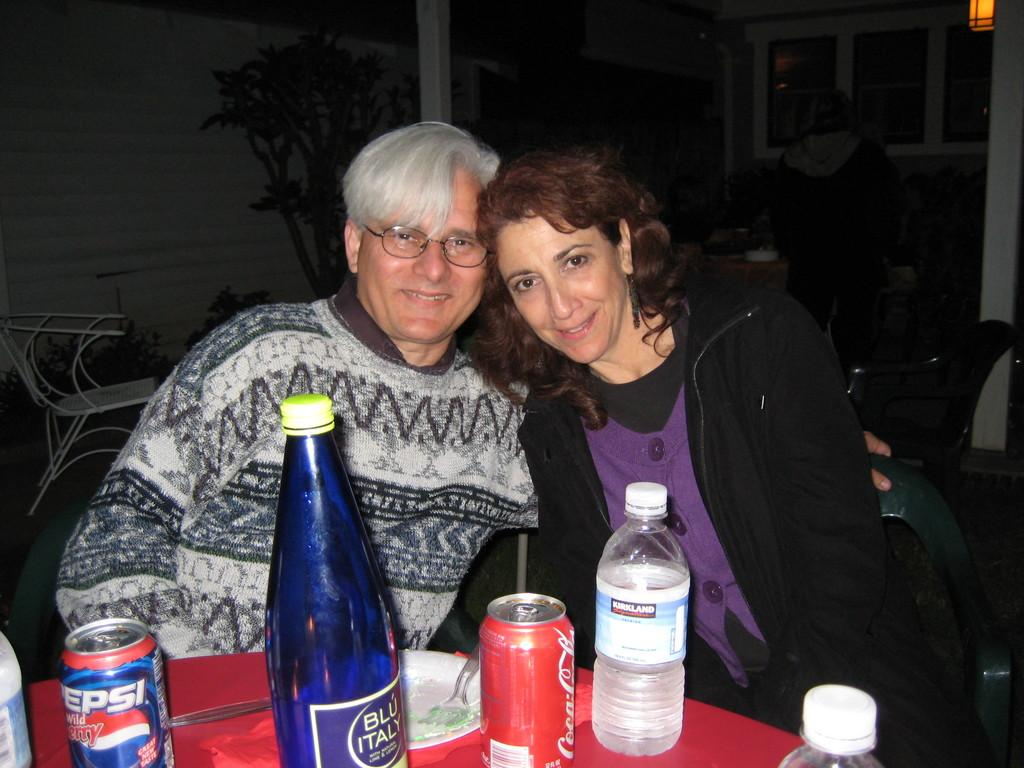How many people are sitting in the image? There are two persons sitting on chairs in the image. What objects can be seen on the table? There are bottles and tins on the table in the image. What type of fowl can be seen in the image? There is no fowl present in the image. What pest is causing damage to the table in the image? There is no pest present in the image, and the table appears undamaged. 